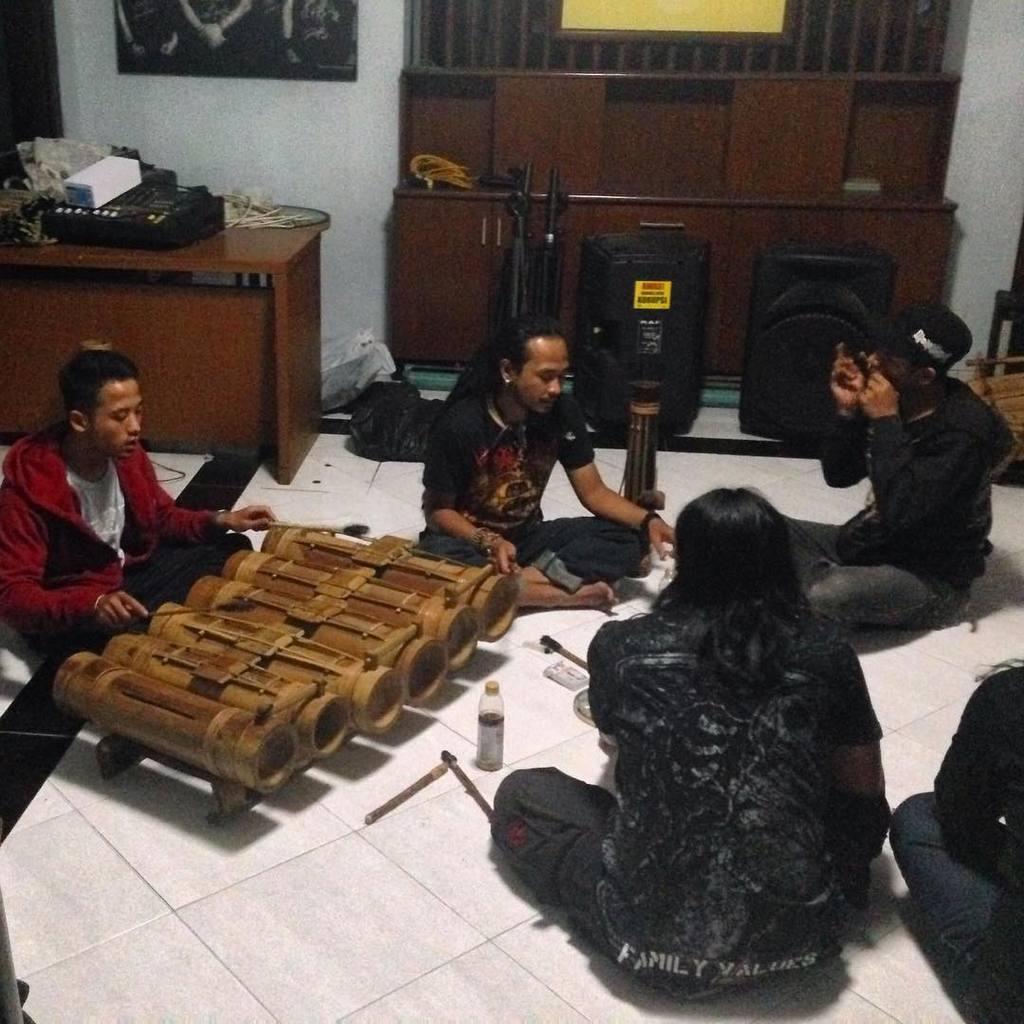Could you give a brief overview of what you see in this image? In this image we can see men are sitting on the floor. At the top of the image, we can see a frame on the wall. In the background, we can see a cupboard, table, bags and some objects. On the table, we can see wires and electronic devices. On the left side of the image, we can see a man is playing a musical instrument. On the floor, we can see a bottle, sticks and some objects. 